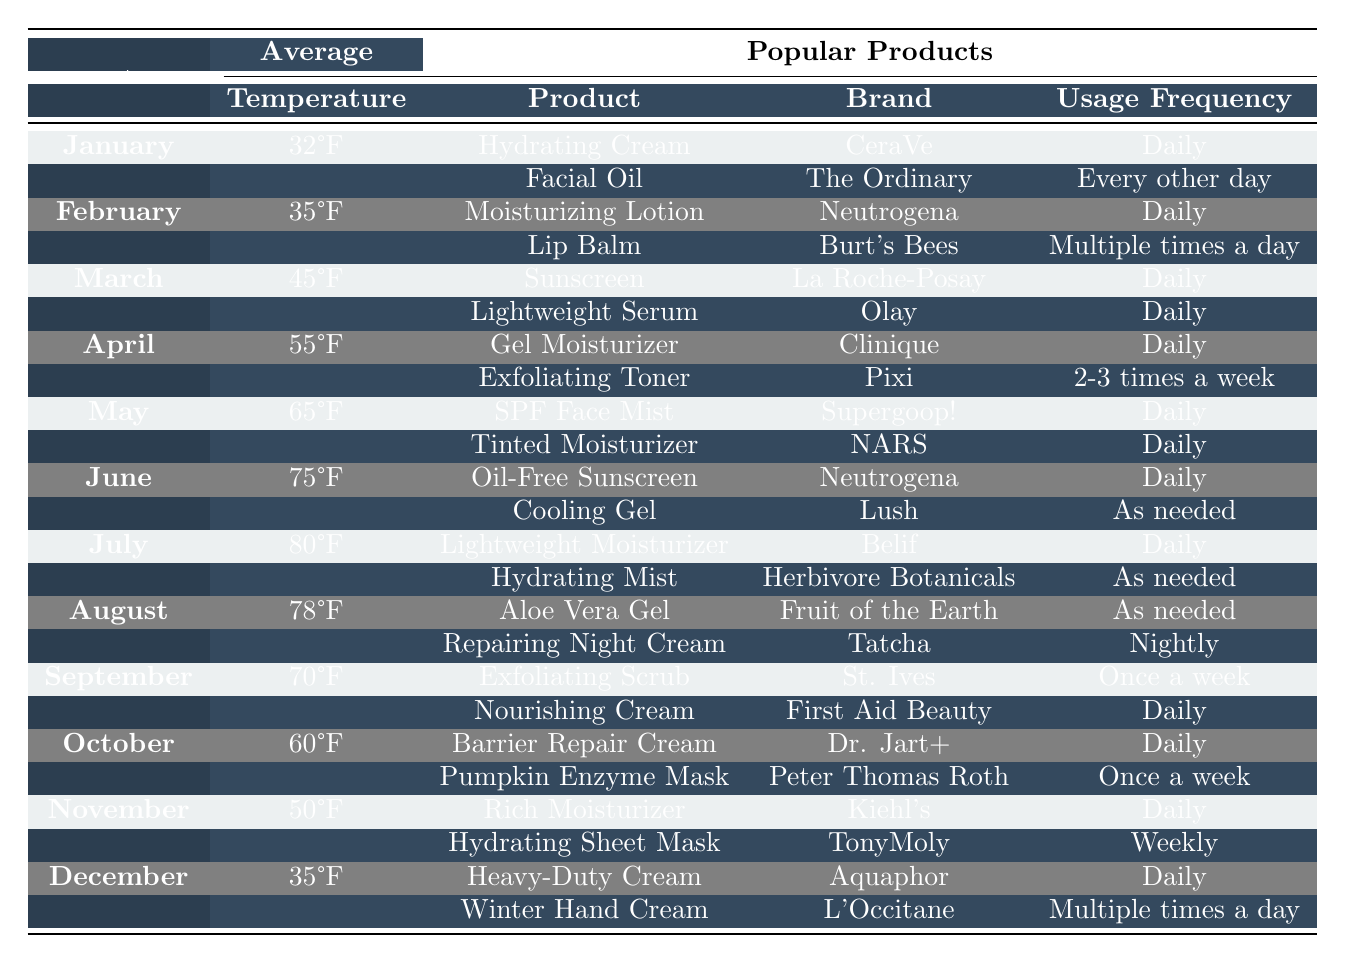What is the most popular product for January? The table shows that the popular products for January are "Hydrating Cream" by CeraVe and "Facial Oil" by The Ordinary. The first mentioned product is typically considered the most popular for that month.
Answer: Hydrating Cream In which month is the average temperature lowest? By examining the average temperatures listed, January has the lowest temperature at 32°F compared to other months.
Answer: January How often is the Tinted Moisturizer used in May? The table states that the Tinted Moisturizer by NARS is used daily in May.
Answer: Daily Is there a month where the popular products include both a daily product and one used "as needed"? June features "Oil-Free Sunscreen" used daily and "Cooling Gel" used as needed, fulfilling this criteria.
Answer: Yes What product is used as often as the Facial Oil in January? The Facial Oil is used every other day, but the table doesn't list another product with the same usage frequency.
Answer: No other product matches Which month has the highest average temperature and what are its popular products? The table shows that July has the highest average temperature at 80°F, with the popular products being "Lightweight Moisturizer" by Belif and "Hydrating Mist" by Herbivore Botanicals.
Answer: July, Lightweight Moisturizer, Hydrating Mist How many times per week is the Exfoliating Toner used in April? According to the table, the Exfoliating Toner by Pixi is used 2-3 times a week during April.
Answer: 2-3 times a week Which product used in December is most frequently applied? The "Winter Hand Cream" by L'Occitane is used multiple times a day, which indicates it is applied more frequently than other products.
Answer: Winter Hand Cream What is the common usage frequency for both products in March? The products in March, "Sunscreen" and "Lightweight Serum," are both used daily, making this their common usage frequency.
Answer: Daily How does the average temperature in August compare to that in May? August has an average temperature of 78°F, while May has an average temperature of 65°F. The difference is 13°F (78°F - 65°F = 13°F).
Answer: 13°F higher in August 